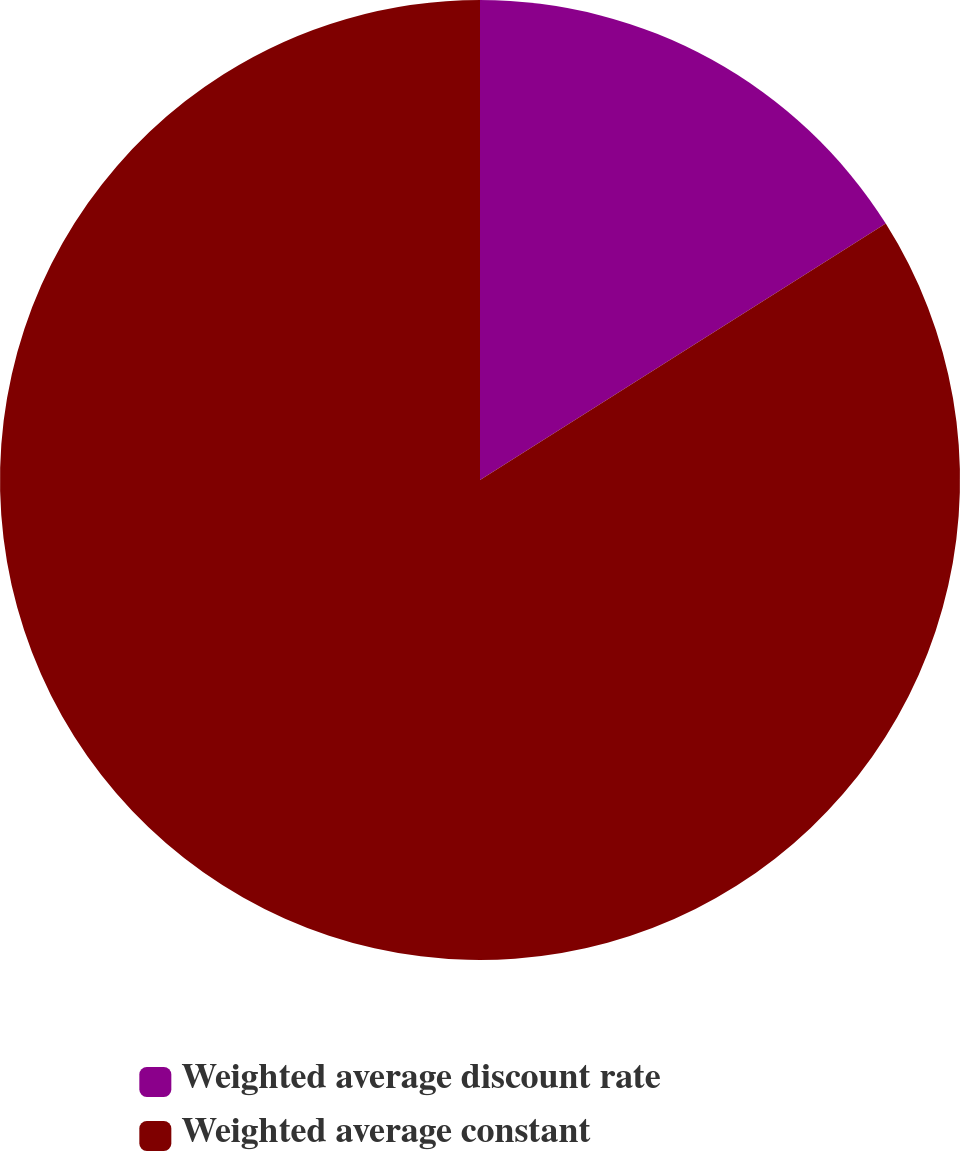Convert chart to OTSL. <chart><loc_0><loc_0><loc_500><loc_500><pie_chart><fcel>Weighted average discount rate<fcel>Weighted average constant<nl><fcel>16.03%<fcel>83.97%<nl></chart> 